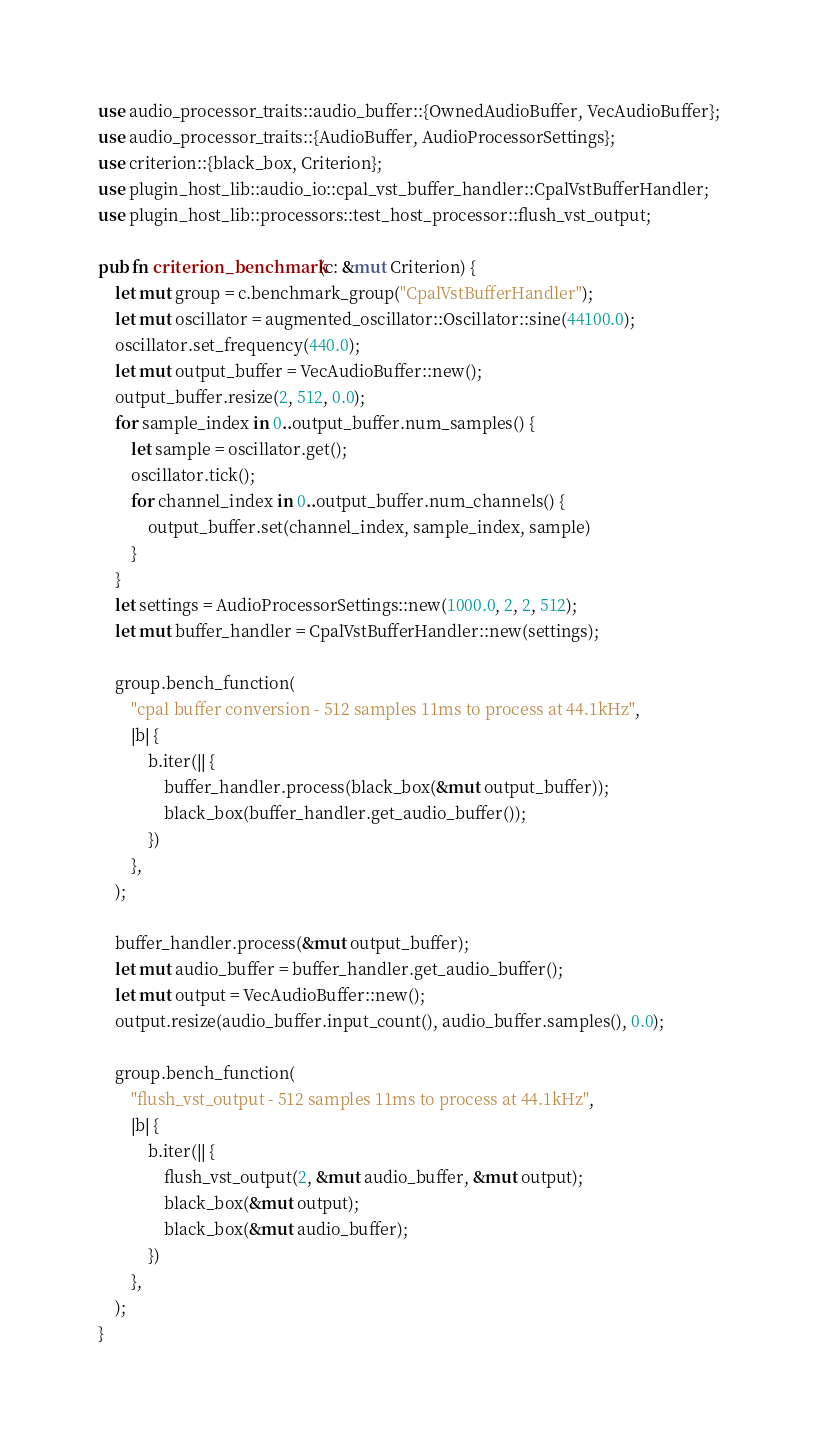Convert code to text. <code><loc_0><loc_0><loc_500><loc_500><_Rust_>use audio_processor_traits::audio_buffer::{OwnedAudioBuffer, VecAudioBuffer};
use audio_processor_traits::{AudioBuffer, AudioProcessorSettings};
use criterion::{black_box, Criterion};
use plugin_host_lib::audio_io::cpal_vst_buffer_handler::CpalVstBufferHandler;
use plugin_host_lib::processors::test_host_processor::flush_vst_output;

pub fn criterion_benchmark(c: &mut Criterion) {
    let mut group = c.benchmark_group("CpalVstBufferHandler");
    let mut oscillator = augmented_oscillator::Oscillator::sine(44100.0);
    oscillator.set_frequency(440.0);
    let mut output_buffer = VecAudioBuffer::new();
    output_buffer.resize(2, 512, 0.0);
    for sample_index in 0..output_buffer.num_samples() {
        let sample = oscillator.get();
        oscillator.tick();
        for channel_index in 0..output_buffer.num_channels() {
            output_buffer.set(channel_index, sample_index, sample)
        }
    }
    let settings = AudioProcessorSettings::new(1000.0, 2, 2, 512);
    let mut buffer_handler = CpalVstBufferHandler::new(settings);

    group.bench_function(
        "cpal buffer conversion - 512 samples 11ms to process at 44.1kHz",
        |b| {
            b.iter(|| {
                buffer_handler.process(black_box(&mut output_buffer));
                black_box(buffer_handler.get_audio_buffer());
            })
        },
    );

    buffer_handler.process(&mut output_buffer);
    let mut audio_buffer = buffer_handler.get_audio_buffer();
    let mut output = VecAudioBuffer::new();
    output.resize(audio_buffer.input_count(), audio_buffer.samples(), 0.0);

    group.bench_function(
        "flush_vst_output - 512 samples 11ms to process at 44.1kHz",
        |b| {
            b.iter(|| {
                flush_vst_output(2, &mut audio_buffer, &mut output);
                black_box(&mut output);
                black_box(&mut audio_buffer);
            })
        },
    );
}
</code> 